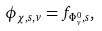Convert formula to latex. <formula><loc_0><loc_0><loc_500><loc_500>\phi _ { \chi , s , v } = f _ { \Phi _ { v } ^ { 0 } , s } ,</formula> 